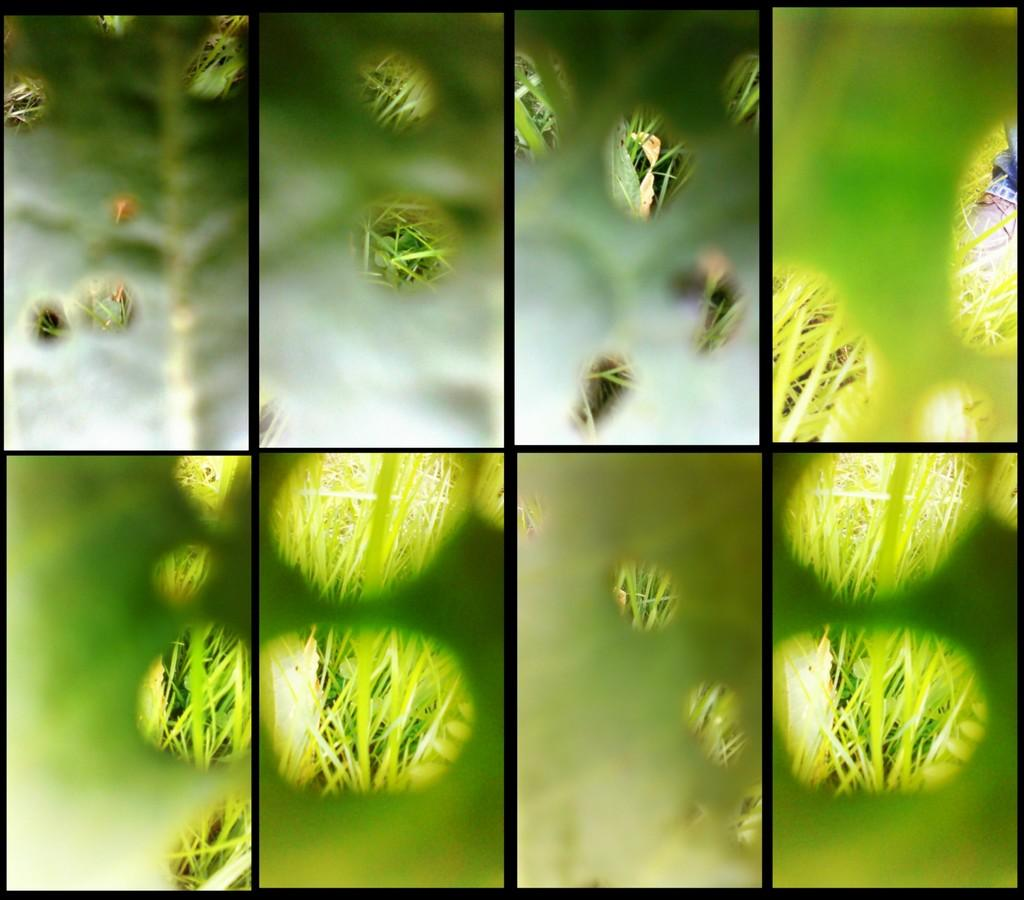What type of image is shown in the collage? The image is a collage. What type of natural environment can be seen in the image? There is grass visible in the image. How would you describe the clarity of the image? The image is blurred. What type of skin is visible on the person in the image? There is no person visible in the image, as it is a collage of grass and is blurred. 